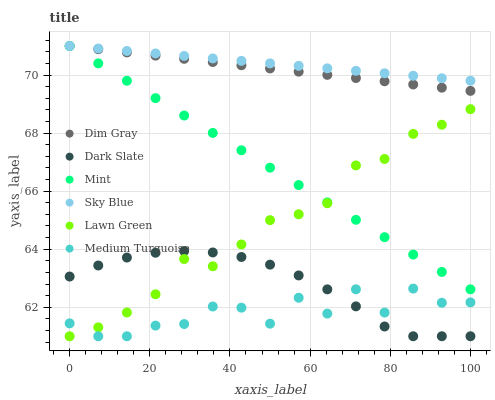Does Medium Turquoise have the minimum area under the curve?
Answer yes or no. Yes. Does Sky Blue have the maximum area under the curve?
Answer yes or no. Yes. Does Dim Gray have the minimum area under the curve?
Answer yes or no. No. Does Dim Gray have the maximum area under the curve?
Answer yes or no. No. Is Dim Gray the smoothest?
Answer yes or no. Yes. Is Medium Turquoise the roughest?
Answer yes or no. Yes. Is Dark Slate the smoothest?
Answer yes or no. No. Is Dark Slate the roughest?
Answer yes or no. No. Does Lawn Green have the lowest value?
Answer yes or no. Yes. Does Dim Gray have the lowest value?
Answer yes or no. No. Does Mint have the highest value?
Answer yes or no. Yes. Does Dark Slate have the highest value?
Answer yes or no. No. Is Lawn Green less than Dim Gray?
Answer yes or no. Yes. Is Dim Gray greater than Lawn Green?
Answer yes or no. Yes. Does Dark Slate intersect Medium Turquoise?
Answer yes or no. Yes. Is Dark Slate less than Medium Turquoise?
Answer yes or no. No. Is Dark Slate greater than Medium Turquoise?
Answer yes or no. No. Does Lawn Green intersect Dim Gray?
Answer yes or no. No. 